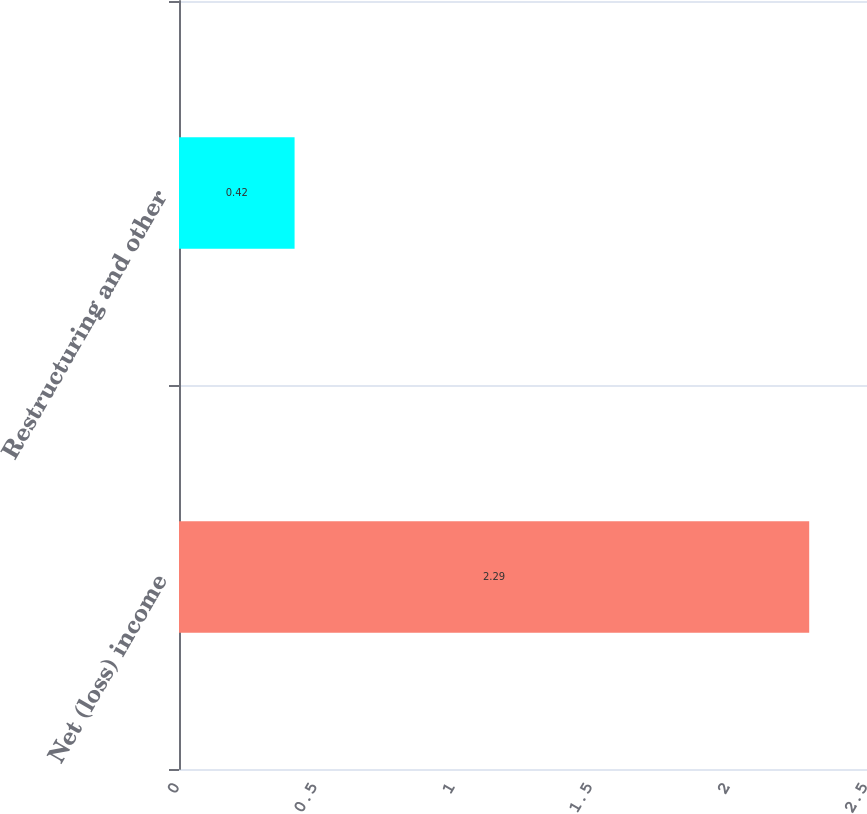<chart> <loc_0><loc_0><loc_500><loc_500><bar_chart><fcel>Net (loss) income<fcel>Restructuring and other<nl><fcel>2.29<fcel>0.42<nl></chart> 